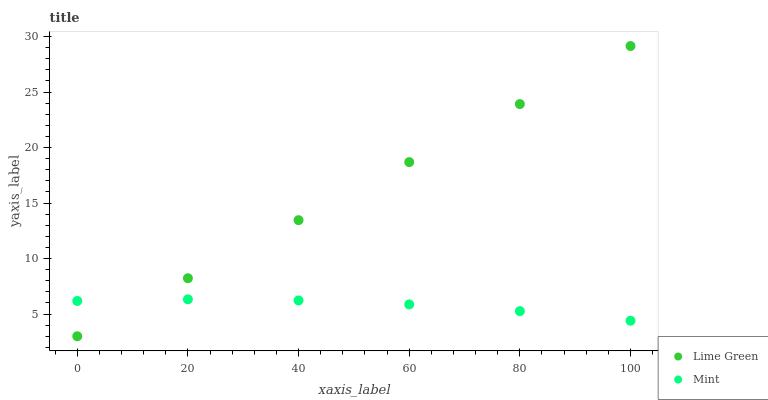Does Mint have the minimum area under the curve?
Answer yes or no. Yes. Does Lime Green have the maximum area under the curve?
Answer yes or no. Yes. Does Lime Green have the minimum area under the curve?
Answer yes or no. No. Is Lime Green the smoothest?
Answer yes or no. Yes. Is Mint the roughest?
Answer yes or no. Yes. Is Lime Green the roughest?
Answer yes or no. No. Does Lime Green have the lowest value?
Answer yes or no. Yes. Does Lime Green have the highest value?
Answer yes or no. Yes. Does Mint intersect Lime Green?
Answer yes or no. Yes. Is Mint less than Lime Green?
Answer yes or no. No. Is Mint greater than Lime Green?
Answer yes or no. No. 